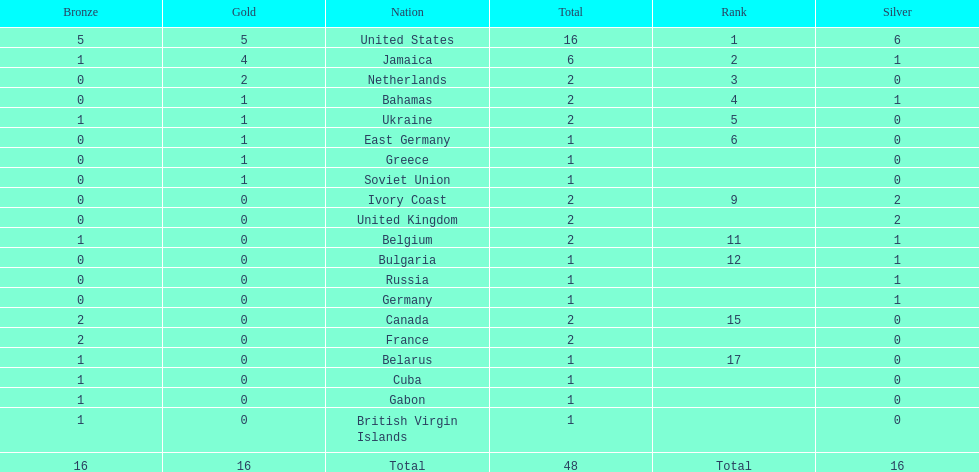Can you give me this table as a dict? {'header': ['Bronze', 'Gold', 'Nation', 'Total', 'Rank', 'Silver'], 'rows': [['5', '5', 'United States', '16', '1', '6'], ['1', '4', 'Jamaica', '6', '2', '1'], ['0', '2', 'Netherlands', '2', '3', '0'], ['0', '1', 'Bahamas', '2', '4', '1'], ['1', '1', 'Ukraine', '2', '5', '0'], ['0', '1', 'East Germany', '1', '6', '0'], ['0', '1', 'Greece', '1', '', '0'], ['0', '1', 'Soviet Union', '1', '', '0'], ['0', '0', 'Ivory Coast', '2', '9', '2'], ['0', '0', 'United Kingdom', '2', '', '2'], ['1', '0', 'Belgium', '2', '11', '1'], ['0', '0', 'Bulgaria', '1', '12', '1'], ['0', '0', 'Russia', '1', '', '1'], ['0', '0', 'Germany', '1', '', '1'], ['2', '0', 'Canada', '2', '15', '0'], ['2', '0', 'France', '2', '', '0'], ['1', '0', 'Belarus', '1', '17', '0'], ['1', '0', 'Cuba', '1', '', '0'], ['1', '0', 'Gabon', '1', '', '0'], ['1', '0', 'British Virgin Islands', '1', '', '0'], ['16', '16', 'Total', '48', 'Total', '16']]} After the united states, what country won the most gold medals. Jamaica. 